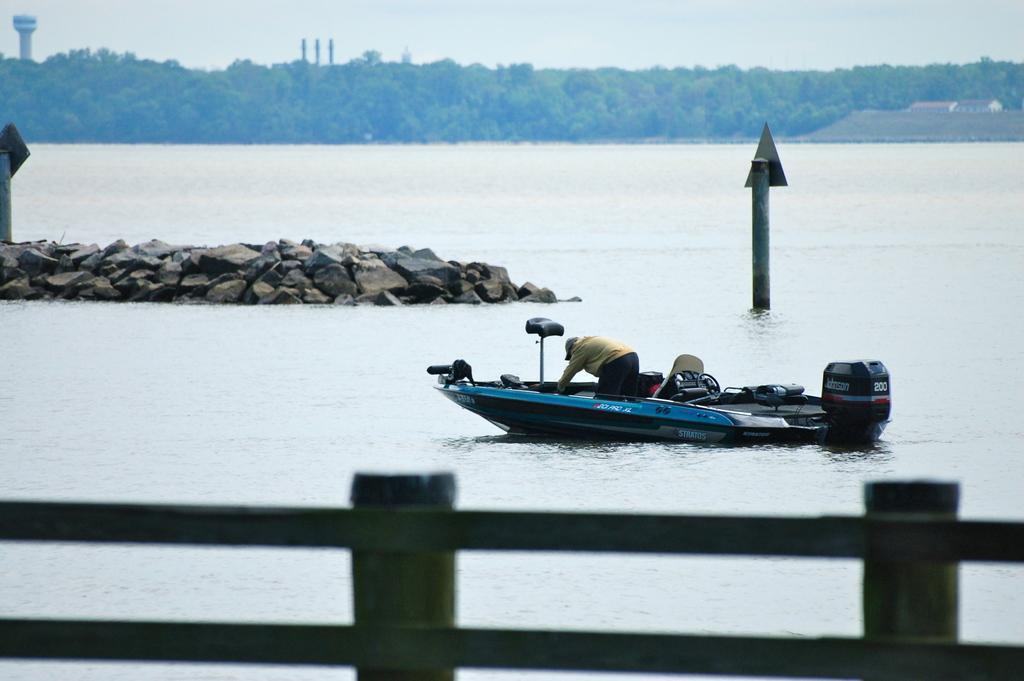Can you describe this image briefly? In this image we can see a boat on the water, there are some stones, trees, houses, fence, poles, boards and a tower, in the background, we can see the sky. 